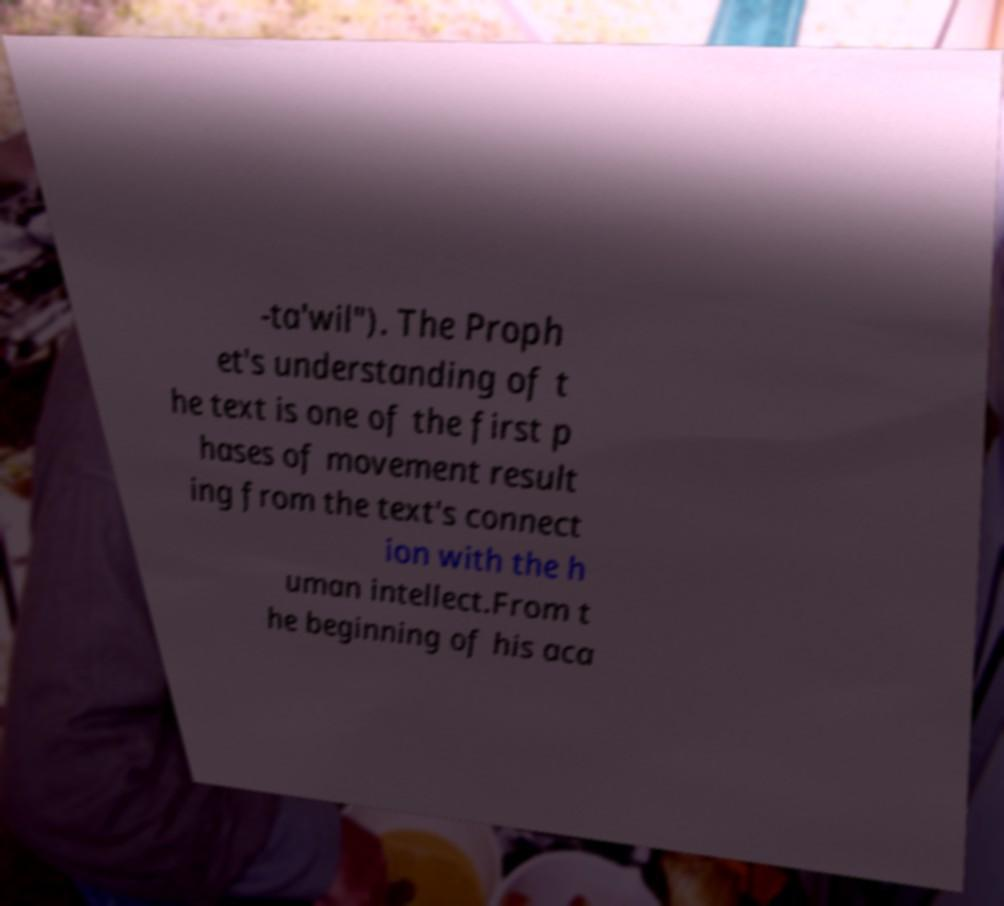What messages or text are displayed in this image? I need them in a readable, typed format. -ta'wil"). The Proph et's understanding of t he text is one of the first p hases of movement result ing from the text's connect ion with the h uman intellect.From t he beginning of his aca 